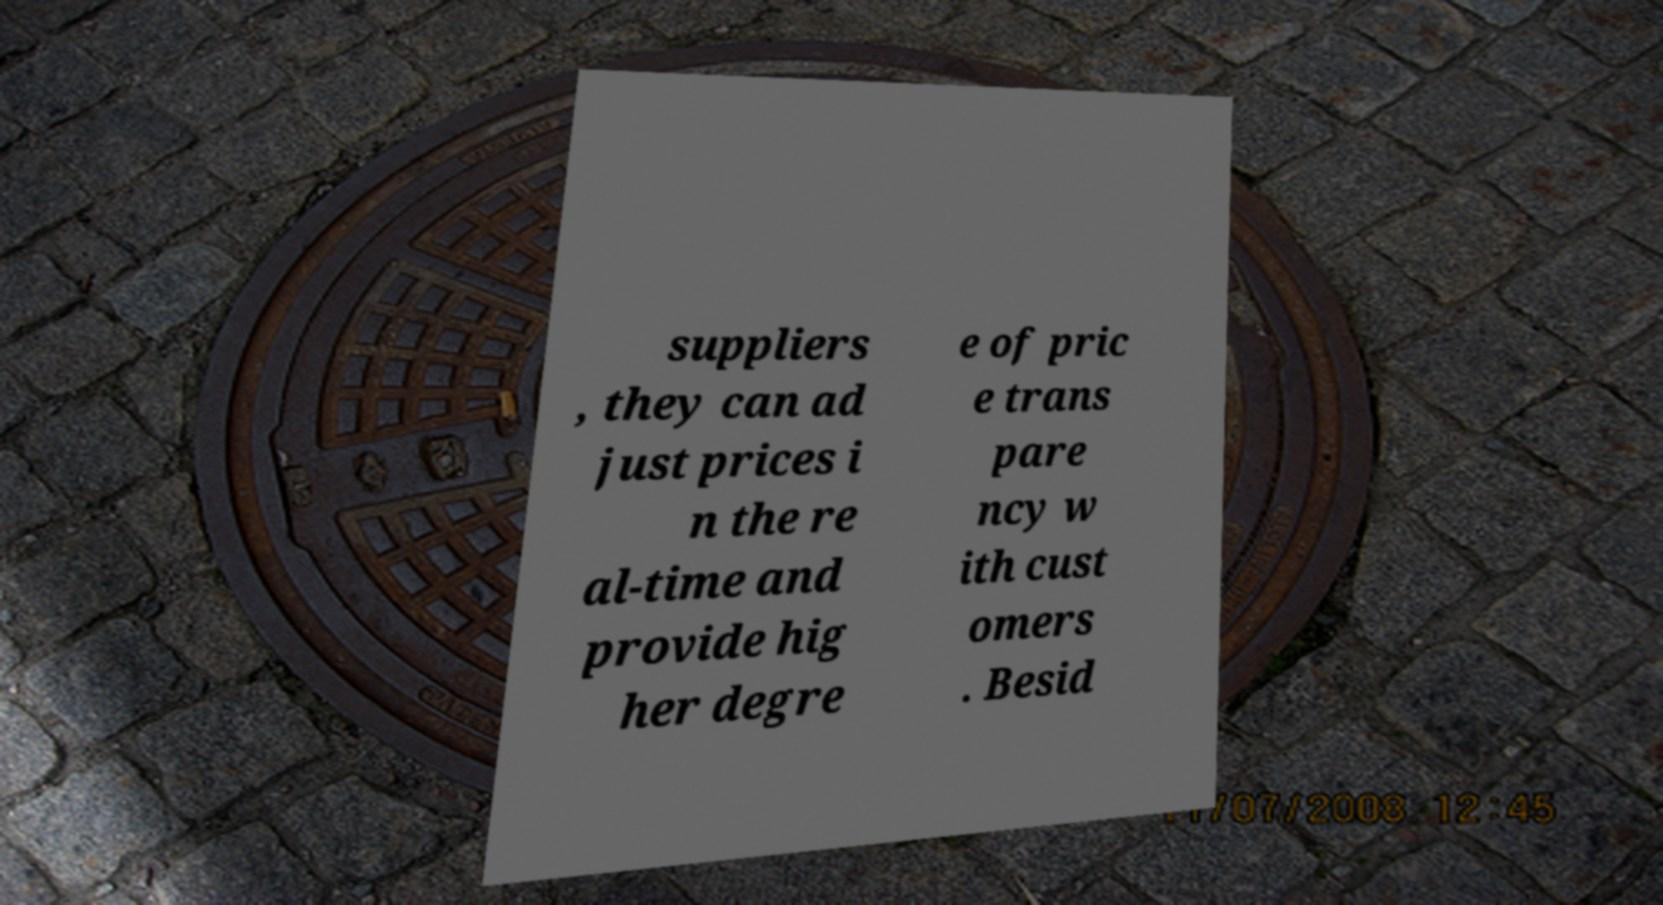I need the written content from this picture converted into text. Can you do that? suppliers , they can ad just prices i n the re al-time and provide hig her degre e of pric e trans pare ncy w ith cust omers . Besid 